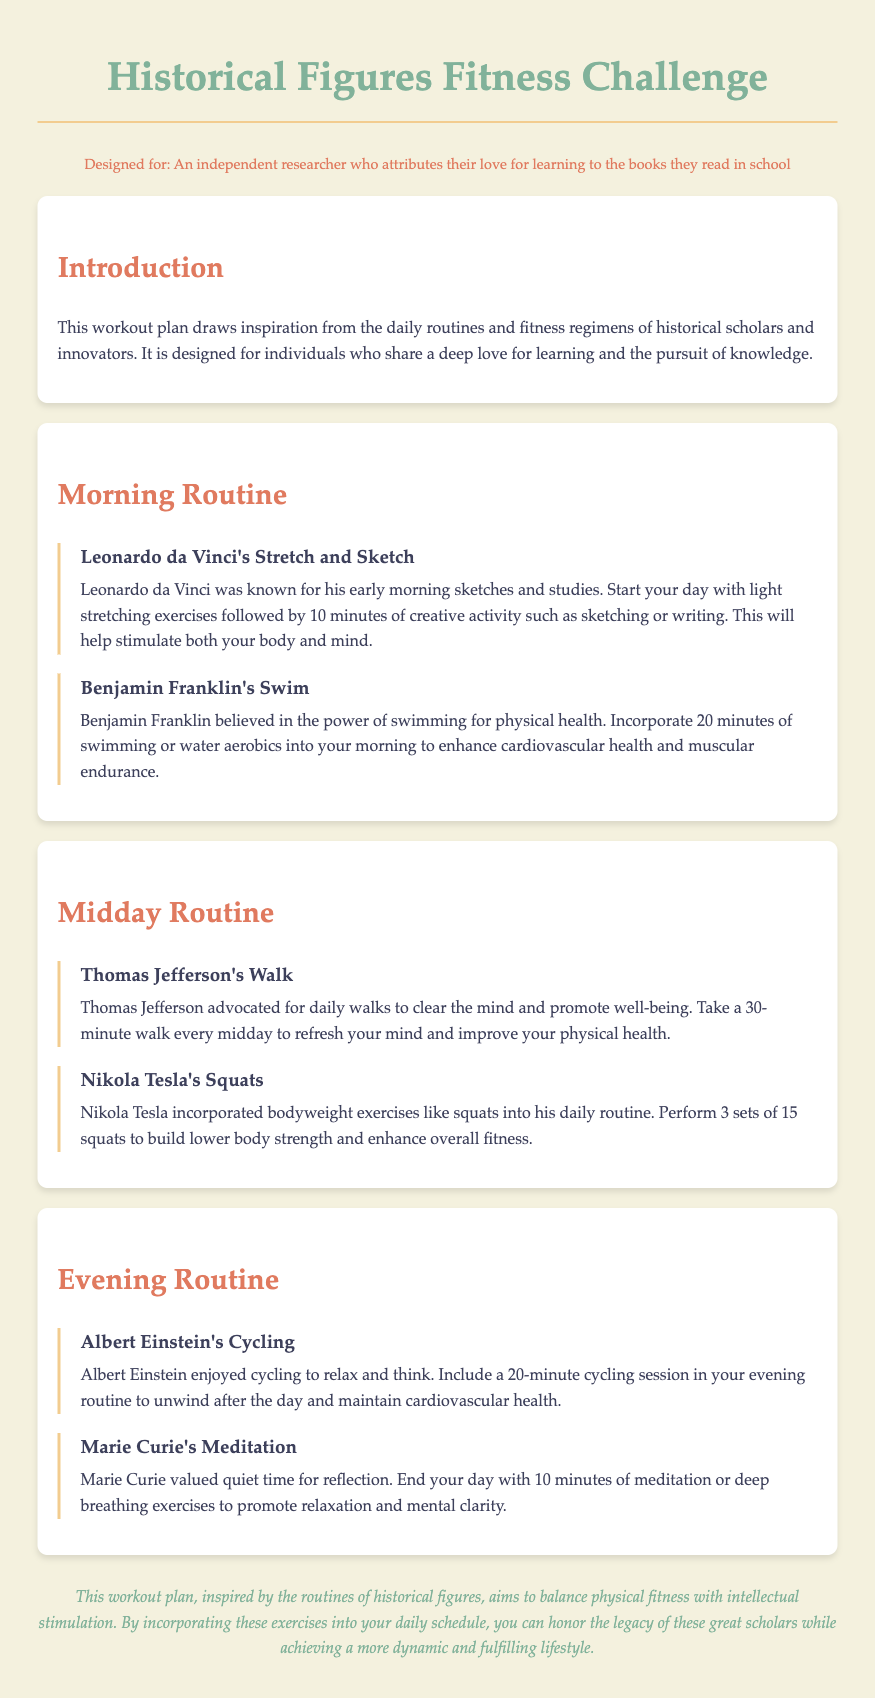what is the title of the workout plan? The title is provided in the main heading of the document, which states "Historical Figures Fitness Challenge."
Answer: Historical Figures Fitness Challenge who was known for early morning sketches and studies? This information is found in the morning routine section, where it mentions Leonardo da Vinci's activities.
Answer: Leonardo da Vinci how long should Benjamin Franklin's swimming session be? The document specifies the duration of swimming in Benjamin Franklin's section of the morning routine.
Answer: 20 minutes what exercise is associated with Thomas Jefferson? This is found in the midday routine section where his recommended activity is mentioned.
Answer: Walk how many squats should Nikola Tesla perform? The document provides details in the midday routine about the number of squats he incorporated into his daily routine.
Answer: 15 what type of exercise does Albert Einstein enjoy? This information is mentioned in the evening routine, specifying what he enjoyed doing to relax.
Answer: Cycling how long should a meditation session last according to Marie Curie? The document states the duration of meditation recommended by Marie Curie in the evening routine section.
Answer: 10 minutes what is the purpose of the workout plan according to the conclusion? The conclusion summarizes the goal of the workout plan, connecting it to physical fitness and intellectual stimulation.
Answer: Balance physical fitness with intellectual stimulation 